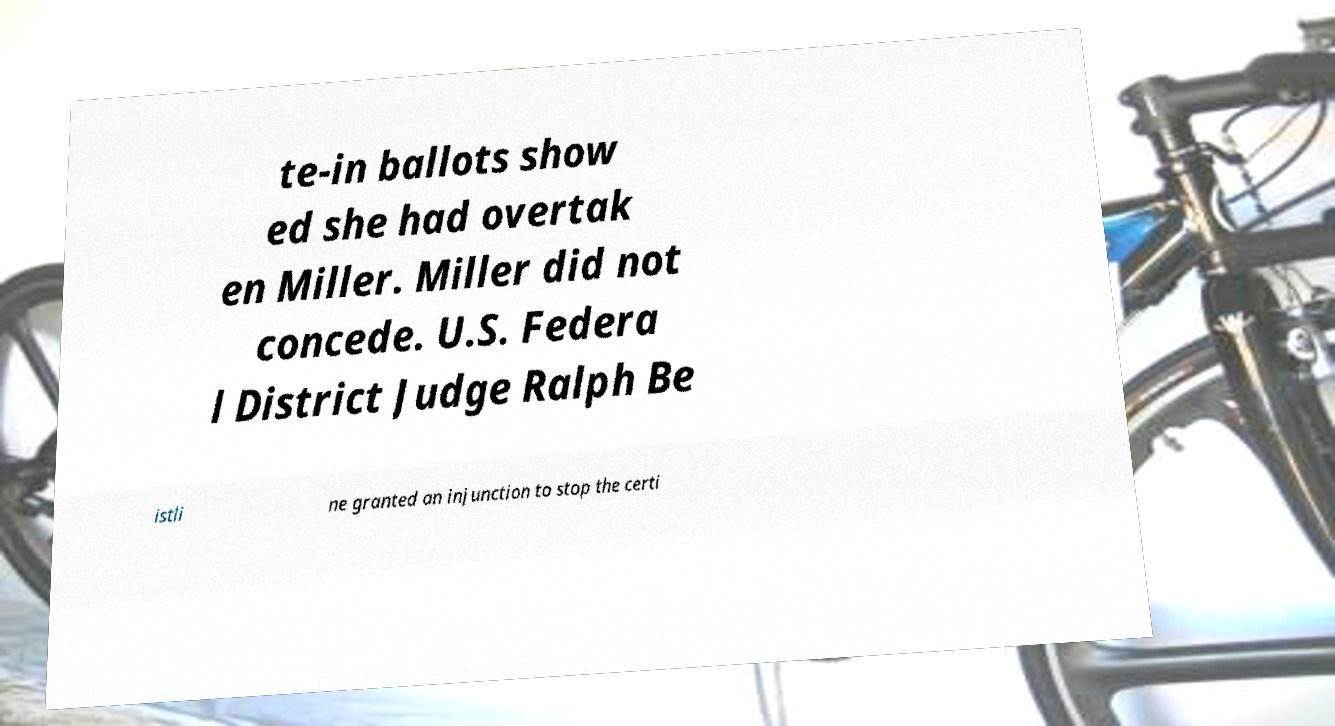Please identify and transcribe the text found in this image. te-in ballots show ed she had overtak en Miller. Miller did not concede. U.S. Federa l District Judge Ralph Be istli ne granted an injunction to stop the certi 